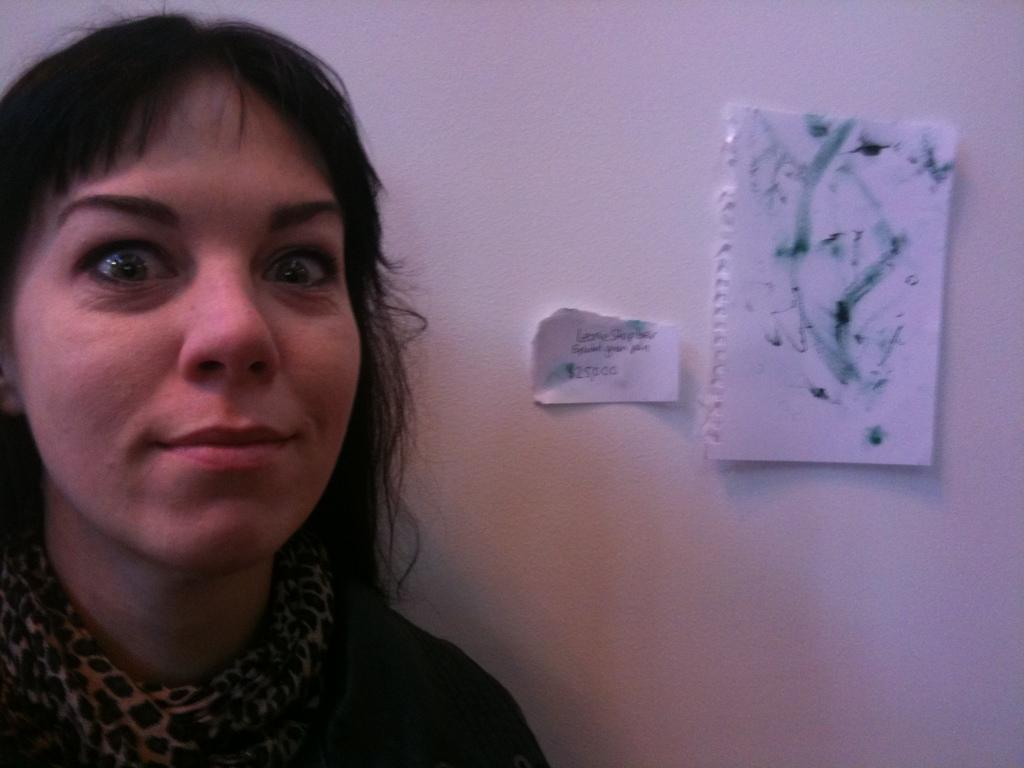What is the main subject of the image? There is a person standing in the image. Where is the person standing in relation to the wall? The person is standing near a wall. What can be seen attached to the wall? There are pipes attached to the wall. How many books are stacked on the pail in the image? There is no pail or books present in the image. What type of pet can be seen interacting with the person in the image? There is no pet present in the image; only the person and the wall with pipes are visible. 